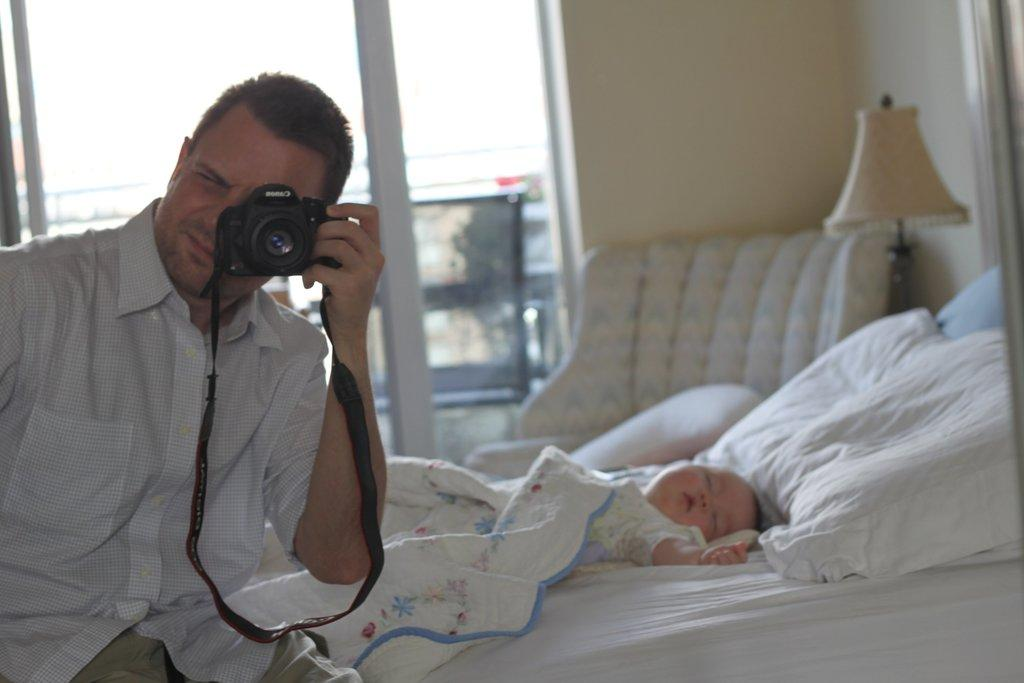What is the person in the image doing? The person is sitting on the bed and capturing a picture. Who else is present in the image? There is a kid sleeping beside the person. What can be seen in the background of the image? There is a window, a wall, a lamp, and a chair in the background. How many jellyfish can be seen swimming in the background of the image? There are no jellyfish present in the image; the background elements include a window, a wall, a lamp, and a chair. 